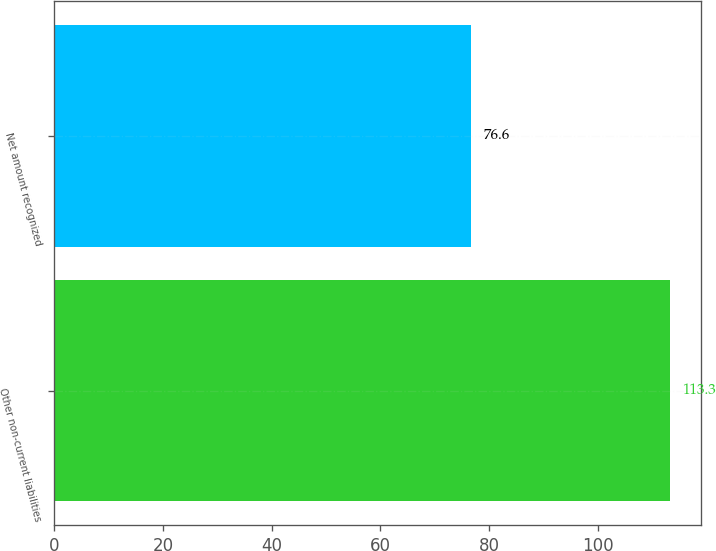Convert chart to OTSL. <chart><loc_0><loc_0><loc_500><loc_500><bar_chart><fcel>Other non-current liabilities<fcel>Net amount recognized<nl><fcel>113.3<fcel>76.6<nl></chart> 